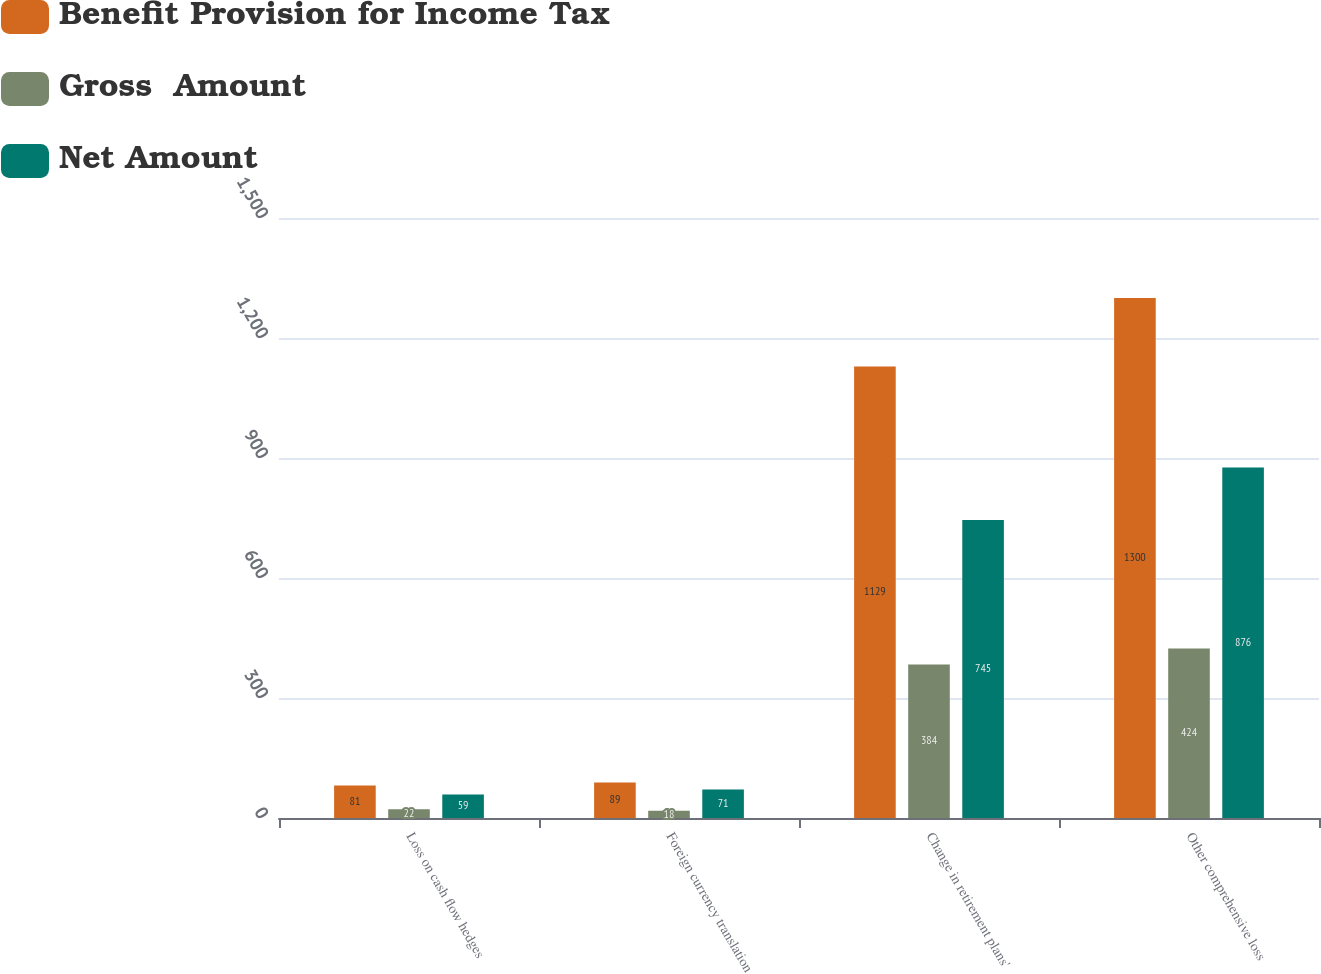Convert chart. <chart><loc_0><loc_0><loc_500><loc_500><stacked_bar_chart><ecel><fcel>Loss on cash flow hedges<fcel>Foreign currency translation<fcel>Change in retirement plans'<fcel>Other comprehensive loss<nl><fcel>Benefit Provision for Income Tax<fcel>81<fcel>89<fcel>1129<fcel>1300<nl><fcel>Gross  Amount<fcel>22<fcel>18<fcel>384<fcel>424<nl><fcel>Net Amount<fcel>59<fcel>71<fcel>745<fcel>876<nl></chart> 